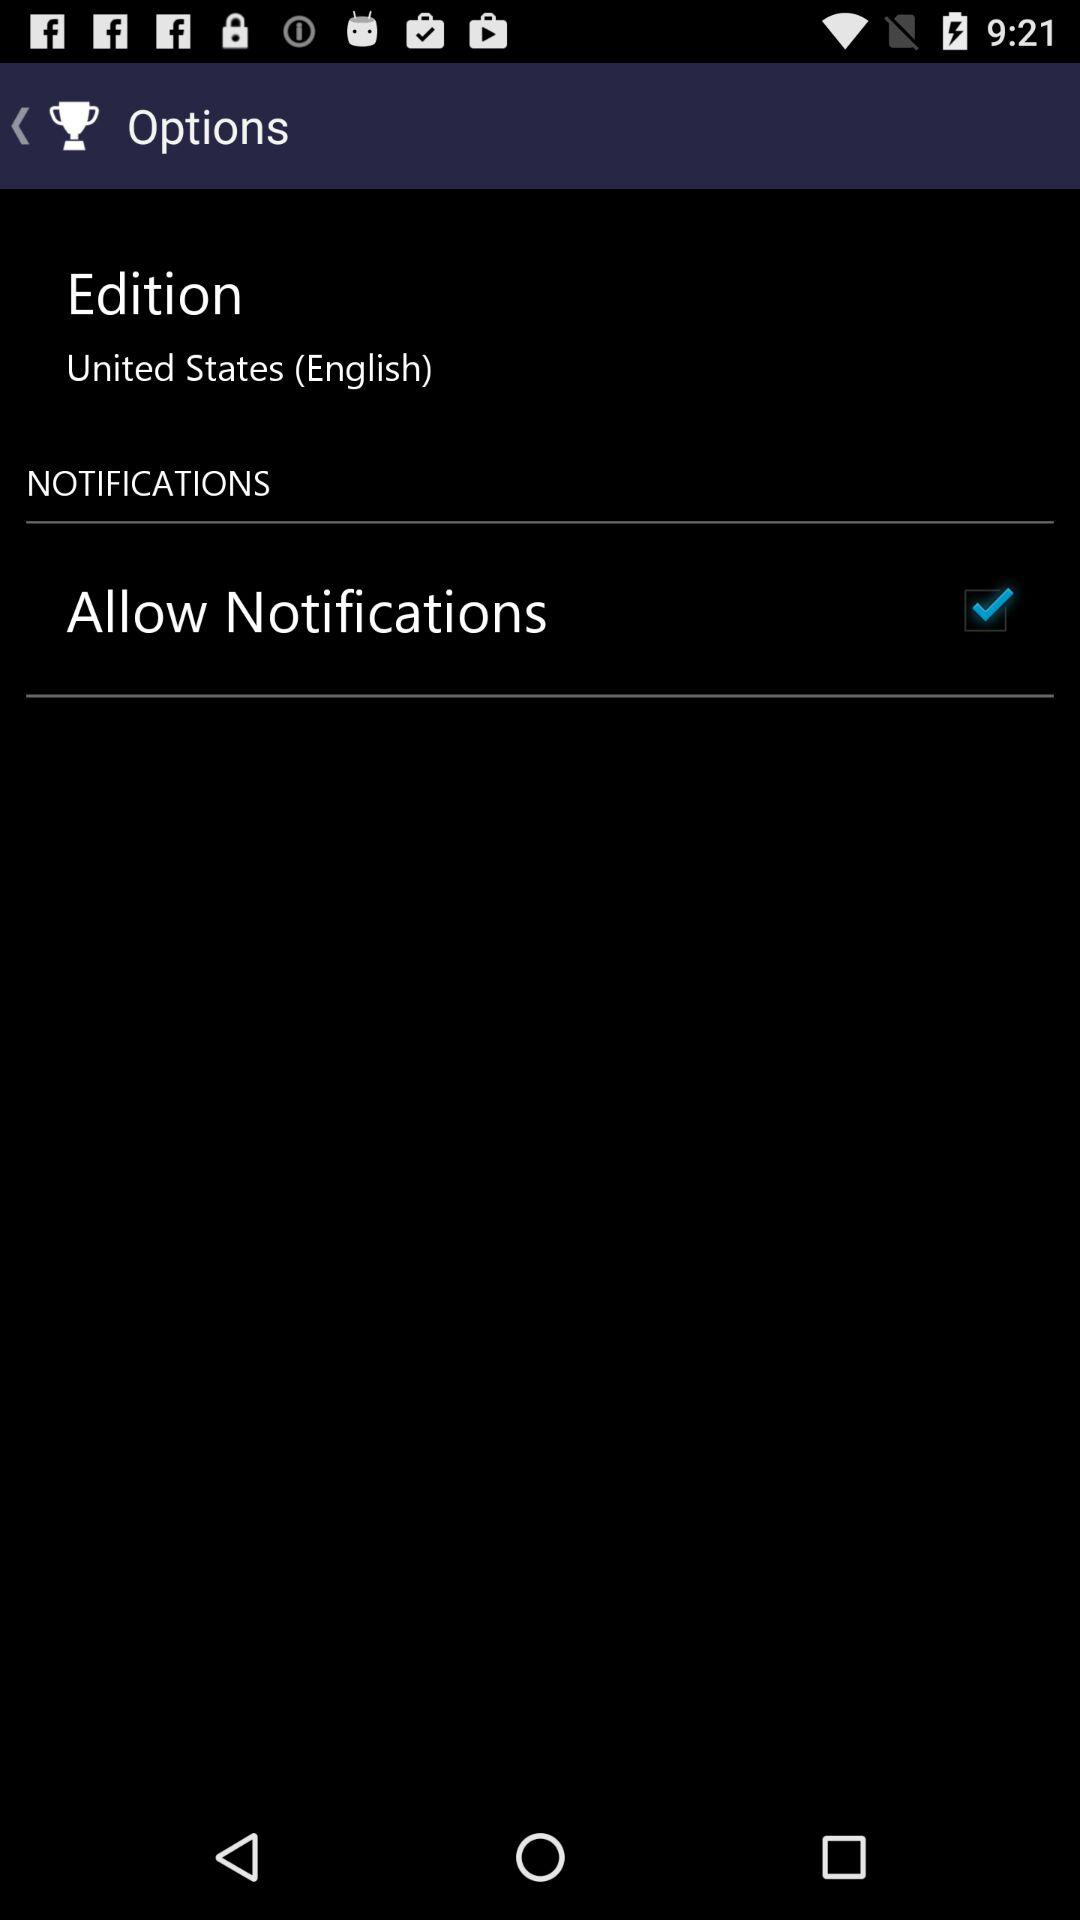What edition is this? This is the United States (English) edition. 